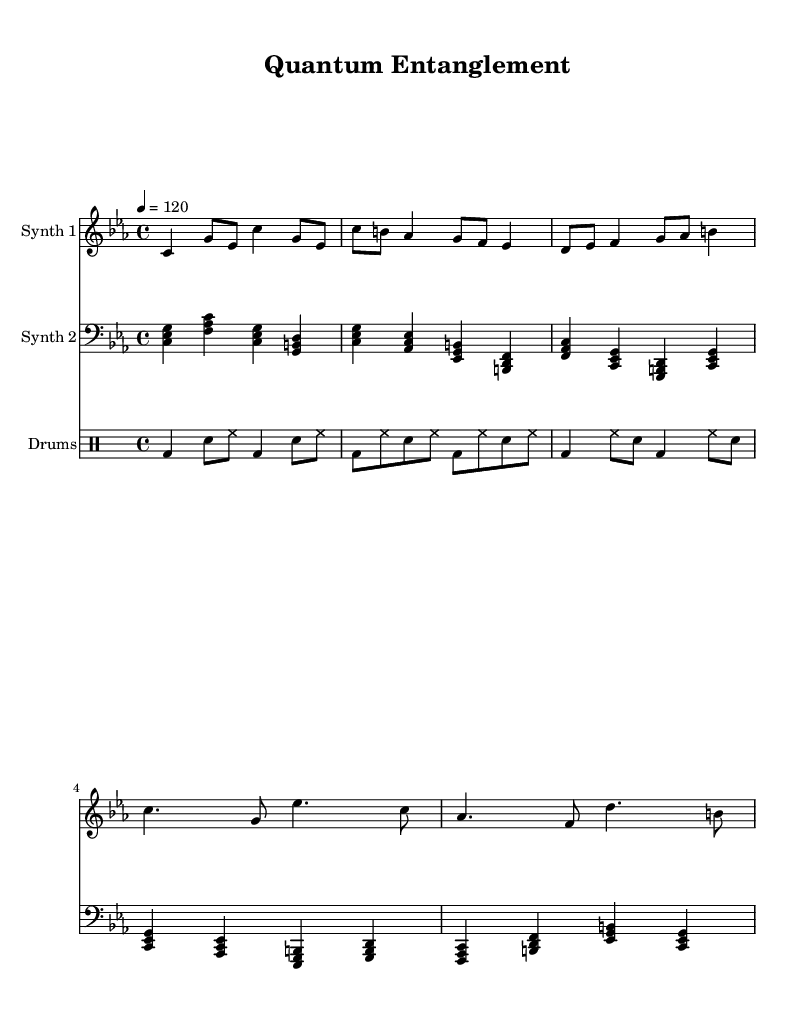What is the key signature of this music? The key signature is C minor, which has three flats (B flat, E flat, and A flat). This can be identified from the 'key' directive indicating 'c' and the indication of 'minor'.
Answer: C minor What is the time signature of this music? The time signature is 4/4, which means there are four beats in each measure and the quarter note gets the beat. This is denoted by the 'time' directive showing '4/4'.
Answer: 4/4 What is the tempo of this music? The tempo is set at a quarter note equals 120 beats per minute, as indicated by 'tempo 4 = 120'.
Answer: 120 How many distinct sections are in the piece? The piece has three distinct sections: an intro, a verse, and a chorus. This can be identified from the repeating structural labels within the music notation.
Answer: 3 What types of instruments are represented in the score? The score features two synthesizers and a drum set, which are identifiable by the labels "Synth 1," "Synth 2," and "Drums."
Answer: Two synthesizers and a drum set Which part includes the bass clef? The part labeled "Synth 2" is written in bass clef, which can be recognized from the clef symbol at the beginning of that staff.
Answer: Synth 2 What rhythmic elements are primarily used in the drum part? The drum part primarily uses bass drum and snare, as indicated by their designations (bd for bass drum and sn for snare) in the drummode.
Answer: Bass drum and snare 